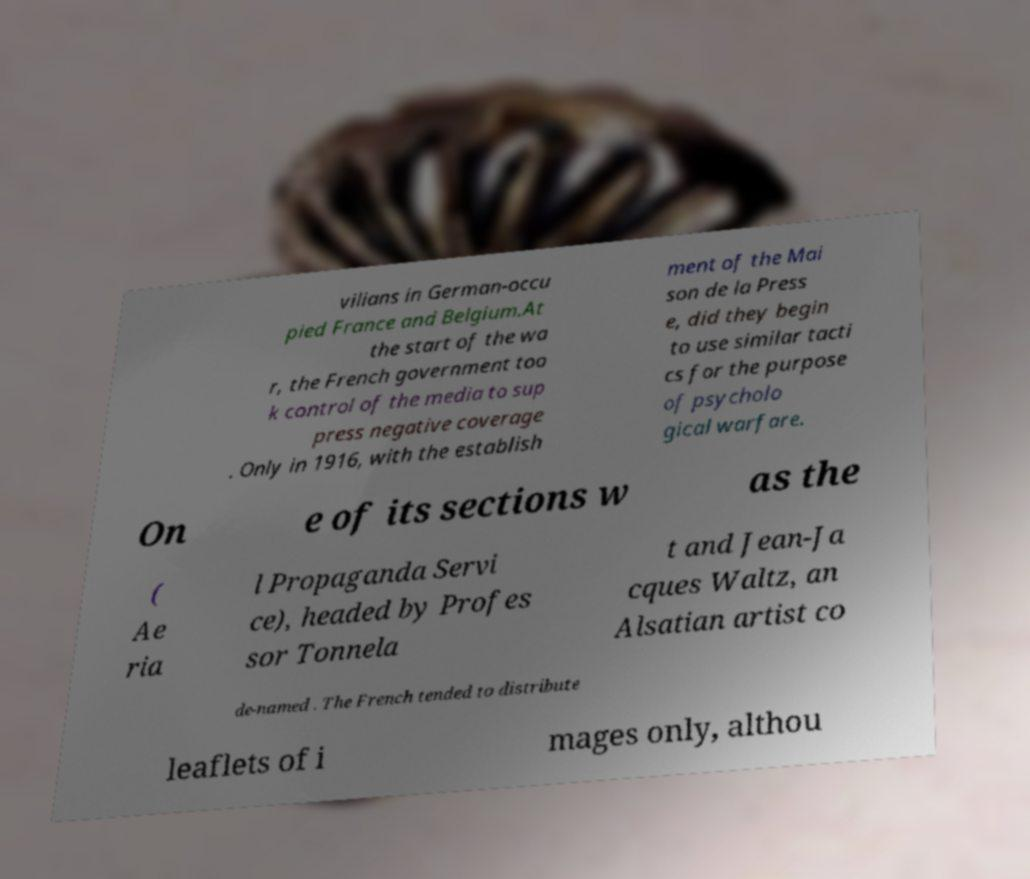There's text embedded in this image that I need extracted. Can you transcribe it verbatim? vilians in German-occu pied France and Belgium.At the start of the wa r, the French government too k control of the media to sup press negative coverage . Only in 1916, with the establish ment of the Mai son de la Press e, did they begin to use similar tacti cs for the purpose of psycholo gical warfare. On e of its sections w as the ( Ae ria l Propaganda Servi ce), headed by Profes sor Tonnela t and Jean-Ja cques Waltz, an Alsatian artist co de-named . The French tended to distribute leaflets of i mages only, althou 